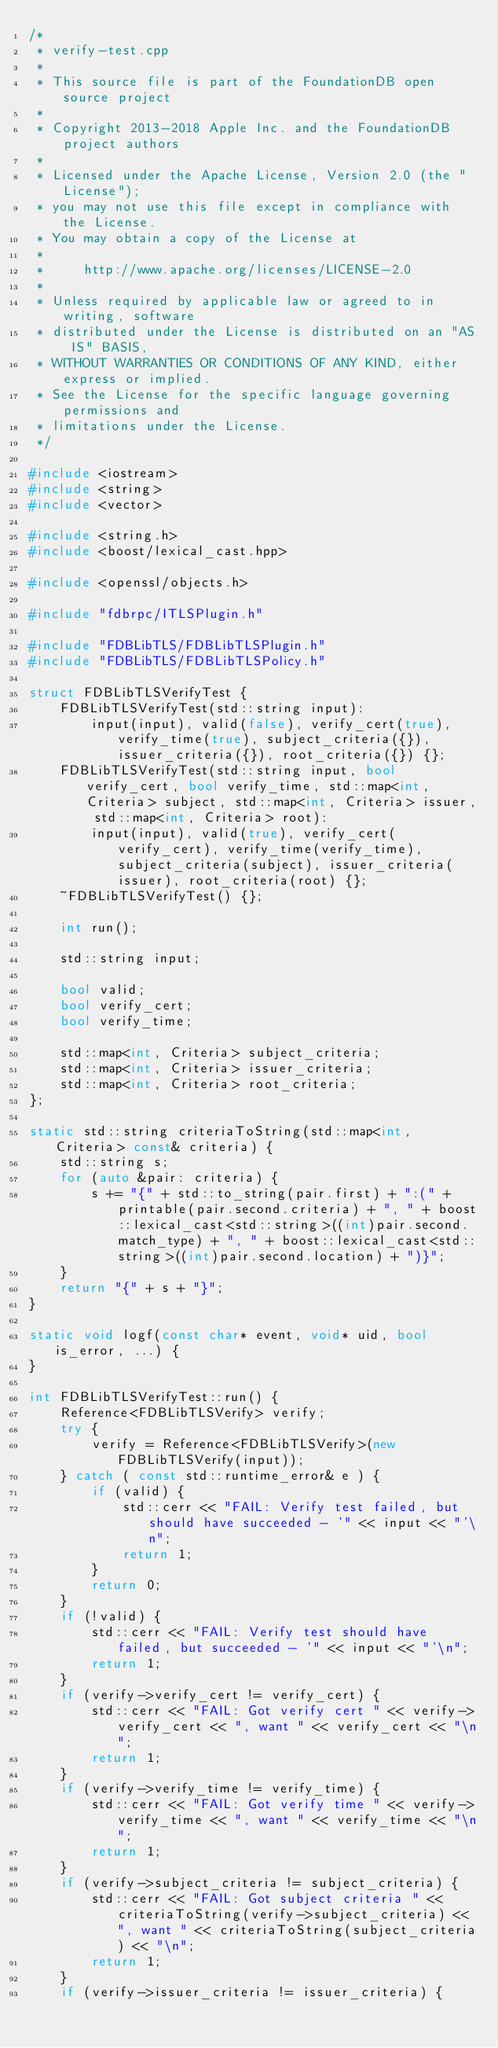<code> <loc_0><loc_0><loc_500><loc_500><_C++_>/*
 * verify-test.cpp
 *
 * This source file is part of the FoundationDB open source project
 *
 * Copyright 2013-2018 Apple Inc. and the FoundationDB project authors
 *
 * Licensed under the Apache License, Version 2.0 (the "License");
 * you may not use this file except in compliance with the License.
 * You may obtain a copy of the License at
 *
 *     http://www.apache.org/licenses/LICENSE-2.0
 *
 * Unless required by applicable law or agreed to in writing, software
 * distributed under the License is distributed on an "AS IS" BASIS,
 * WITHOUT WARRANTIES OR CONDITIONS OF ANY KIND, either express or implied.
 * See the License for the specific language governing permissions and
 * limitations under the License.
 */

#include <iostream>
#include <string>
#include <vector>

#include <string.h>
#include <boost/lexical_cast.hpp>

#include <openssl/objects.h>

#include "fdbrpc/ITLSPlugin.h"

#include "FDBLibTLS/FDBLibTLSPlugin.h"
#include "FDBLibTLS/FDBLibTLSPolicy.h"

struct FDBLibTLSVerifyTest {
	FDBLibTLSVerifyTest(std::string input):
		input(input), valid(false), verify_cert(true), verify_time(true), subject_criteria({}), issuer_criteria({}), root_criteria({}) {};
	FDBLibTLSVerifyTest(std::string input, bool verify_cert, bool verify_time, std::map<int, Criteria> subject, std::map<int, Criteria> issuer, std::map<int, Criteria> root):
		input(input), valid(true), verify_cert(verify_cert), verify_time(verify_time), subject_criteria(subject), issuer_criteria(issuer), root_criteria(root) {};
	~FDBLibTLSVerifyTest() {};

	int run();

	std::string input;

	bool valid;
	bool verify_cert;
	bool verify_time;

	std::map<int, Criteria> subject_criteria;
	std::map<int, Criteria> issuer_criteria;
	std::map<int, Criteria> root_criteria;
};

static std::string criteriaToString(std::map<int, Criteria> const& criteria) {
	std::string s;
	for (auto &pair: criteria) {
		s += "{" + std::to_string(pair.first) + ":(" + printable(pair.second.criteria) + ", " + boost::lexical_cast<std::string>((int)pair.second.match_type) + ", " + boost::lexical_cast<std::string>((int)pair.second.location) + ")}";
	}
	return "{" + s + "}";
}

static void logf(const char* event, void* uid, bool is_error, ...) {
}

int FDBLibTLSVerifyTest::run() {
	Reference<FDBLibTLSVerify> verify;
	try {
		verify = Reference<FDBLibTLSVerify>(new FDBLibTLSVerify(input));
	} catch ( const std::runtime_error& e ) {
		if (valid) {
			std::cerr << "FAIL: Verify test failed, but should have succeeded - '" << input << "'\n";
			return 1;
		}
		return 0;
	}
	if (!valid) {
		std::cerr << "FAIL: Verify test should have failed, but succeeded - '" << input << "'\n";
		return 1;
	}
	if (verify->verify_cert != verify_cert) {
		std::cerr << "FAIL: Got verify cert " << verify->verify_cert << ", want " << verify_cert << "\n";
		return 1;
	}
	if (verify->verify_time != verify_time) {
		std::cerr << "FAIL: Got verify time " << verify->verify_time << ", want " << verify_time << "\n";
		return 1;
	}
	if (verify->subject_criteria != subject_criteria) {
		std::cerr << "FAIL: Got subject criteria " << criteriaToString(verify->subject_criteria) << ", want " << criteriaToString(subject_criteria) << "\n";
		return 1;
	}
	if (verify->issuer_criteria != issuer_criteria) {</code> 